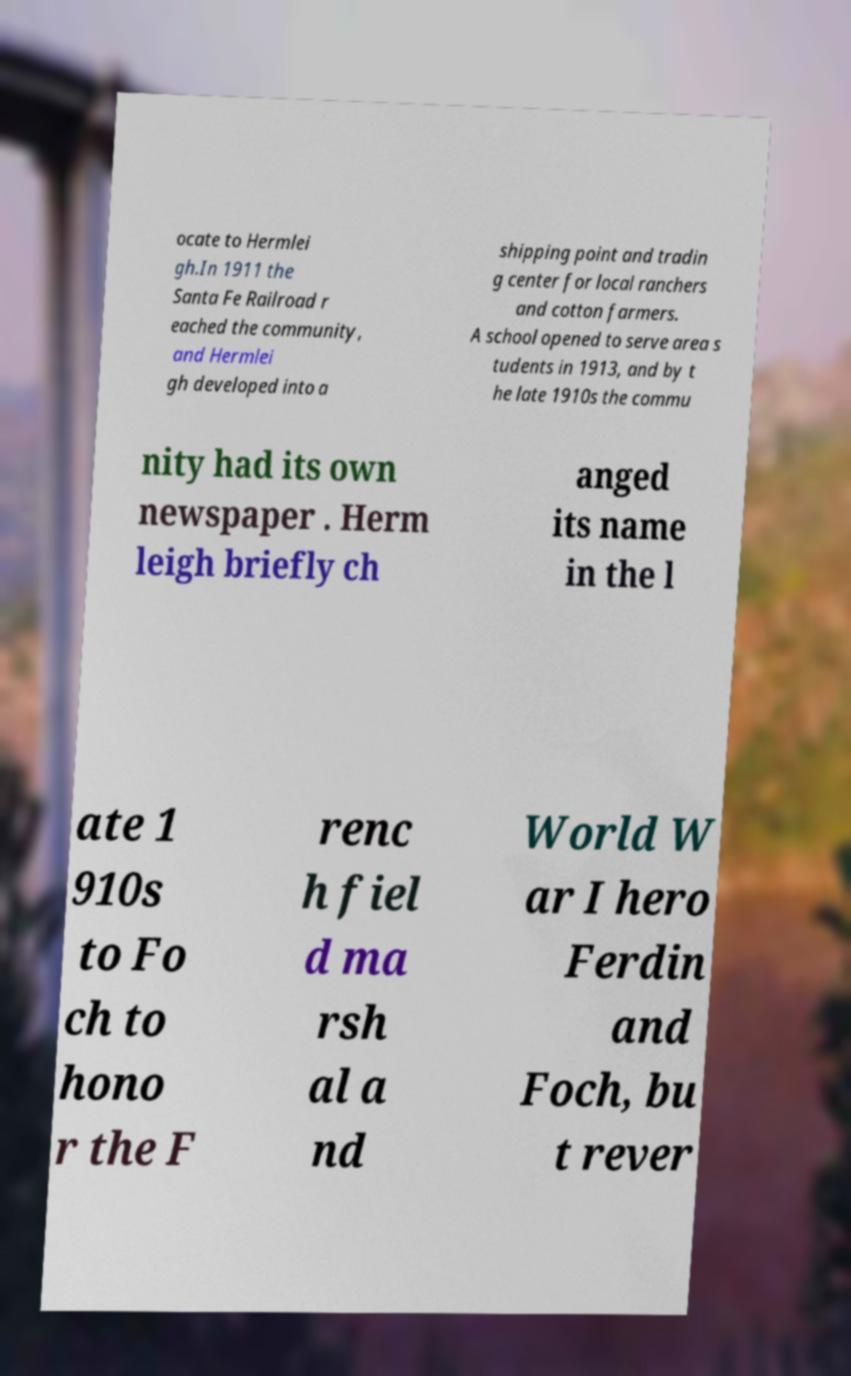What messages or text are displayed in this image? I need them in a readable, typed format. ocate to Hermlei gh.In 1911 the Santa Fe Railroad r eached the community, and Hermlei gh developed into a shipping point and tradin g center for local ranchers and cotton farmers. A school opened to serve area s tudents in 1913, and by t he late 1910s the commu nity had its own newspaper . Herm leigh briefly ch anged its name in the l ate 1 910s to Fo ch to hono r the F renc h fiel d ma rsh al a nd World W ar I hero Ferdin and Foch, bu t rever 